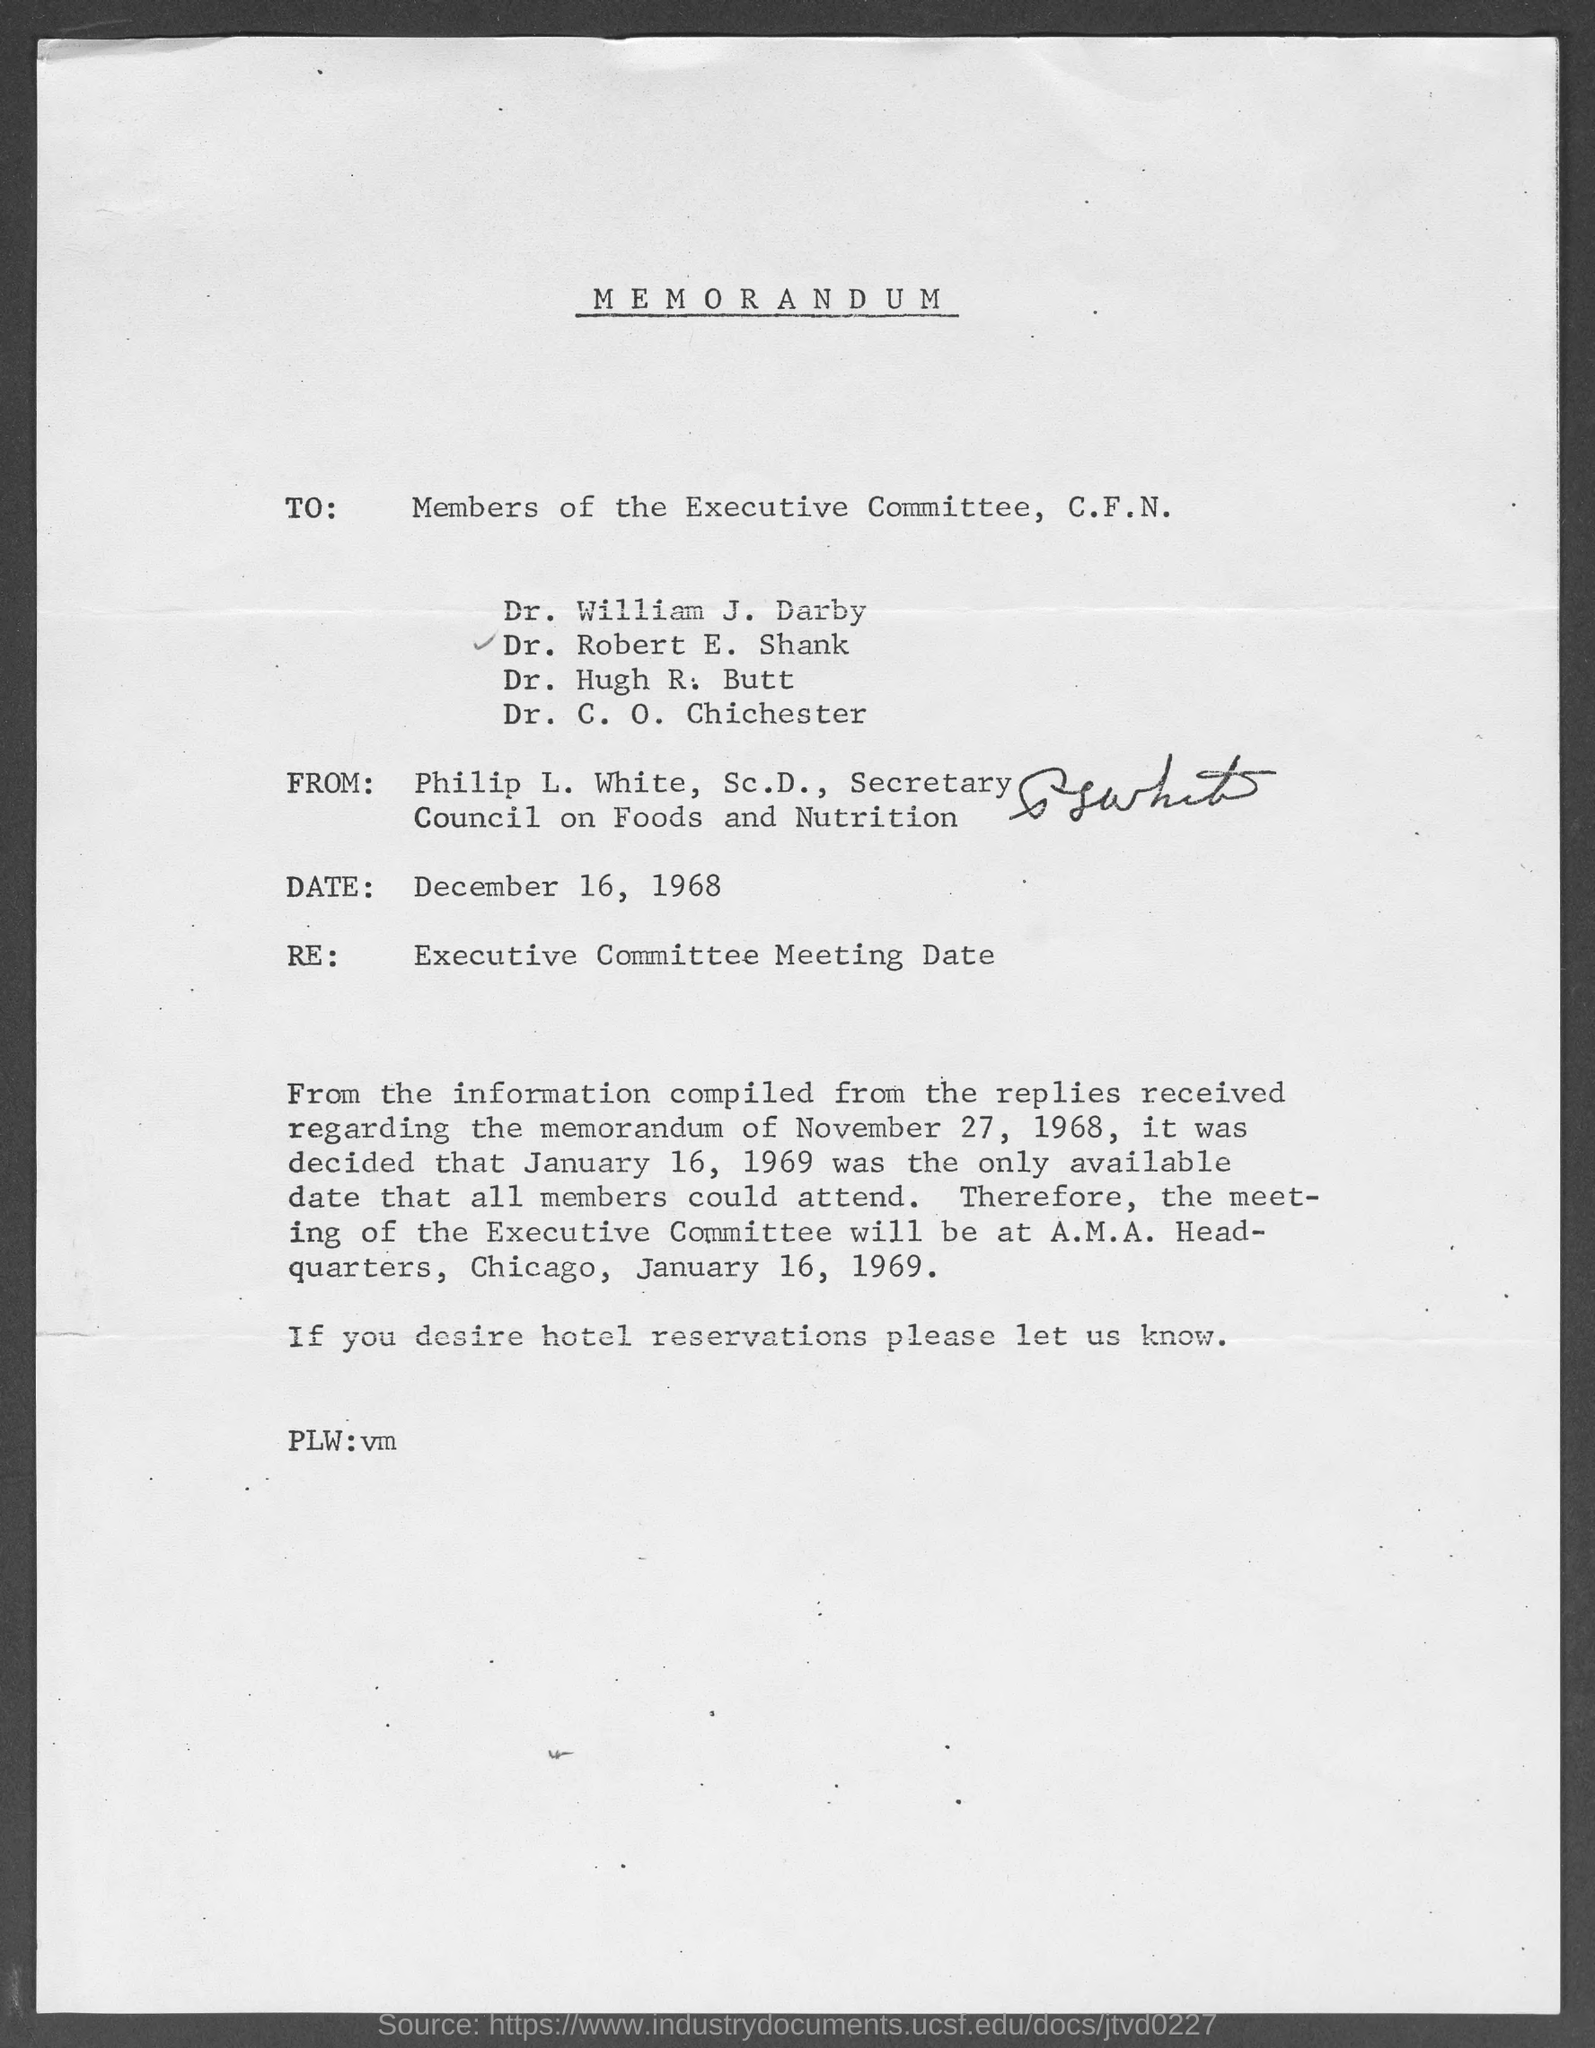Point out several critical features in this image. The Secretary of the Council on Foods and Nutrition is Philip L. White. This is a declaration that states that the document in question is a memorandum. The meeting is scheduled to be held on January 16, 1969. The document is dated December 16, 1968. 